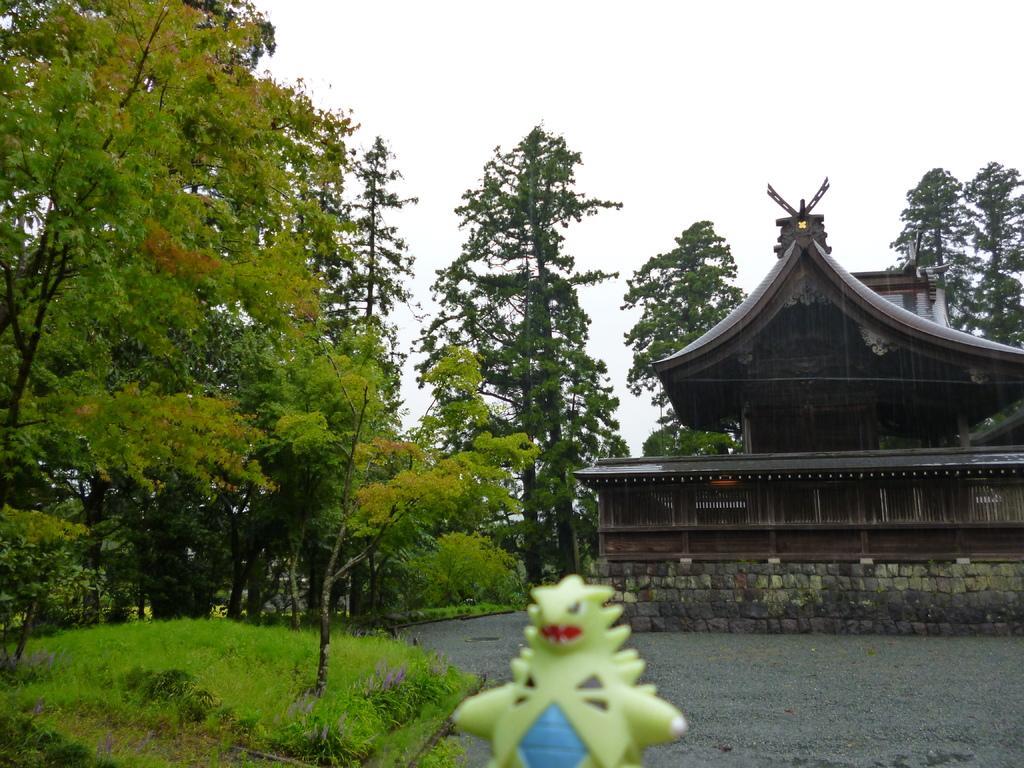In one or two sentences, can you explain what this image depicts? There is a toy at the bottom of this image. We can see trees and a building in the middle of this image. The sky is in the background. 